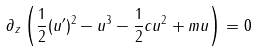Convert formula to latex. <formula><loc_0><loc_0><loc_500><loc_500>\partial _ { z } \left ( \frac { 1 } { 2 } ( u ^ { \prime } ) ^ { 2 } - u ^ { 3 } - \frac { 1 } { 2 } c u ^ { 2 } + m u \right ) = 0</formula> 